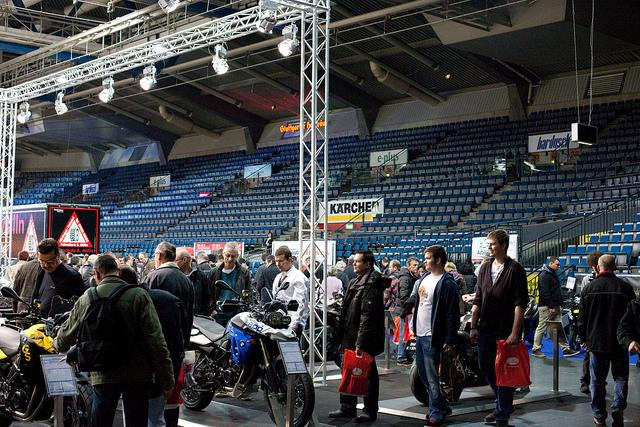What type of vehicle are the people looking at?

Choices:
A) car
B) boat
C) plane
D) motorcycle motorcycle 